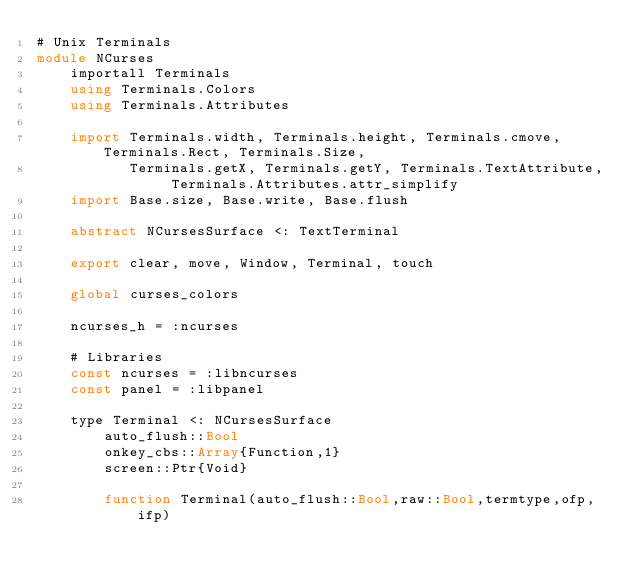Convert code to text. <code><loc_0><loc_0><loc_500><loc_500><_Julia_># Unix Terminals
module NCurses
    importall Terminals
    using Terminals.Colors
    using Terminals.Attributes

    import Terminals.width, Terminals.height, Terminals.cmove, Terminals.Rect, Terminals.Size, 
           Terminals.getX, Terminals.getY, Terminals.TextAttribute, Terminals.Attributes.attr_simplify
    import Base.size, Base.write, Base.flush

    abstract NCursesSurface <: TextTerminal

    export clear, move, Window, Terminal, touch

    global curses_colors

    ncurses_h = :ncurses
    
    # Libraries
    const ncurses = :libncurses
    const panel = :libpanel

    type Terminal <: NCursesSurface
        auto_flush::Bool
        onkey_cbs::Array{Function,1}
        screen::Ptr{Void}

        function Terminal(auto_flush::Bool,raw::Bool,termtype,ofp,ifp)</code> 